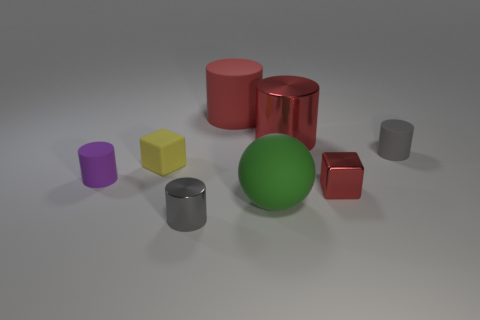Are there any other things that are the same shape as the big green thing?
Give a very brief answer. No. What number of gray objects are the same size as the matte block?
Your response must be concise. 2. How many green things are tiny matte cubes or metallic objects?
Give a very brief answer. 0. Is the number of small metal cubes that are behind the large red metallic cylinder the same as the number of metal things?
Offer a very short reply. No. There is a gray object in front of the rubber cube; how big is it?
Give a very brief answer. Small. What number of other metallic things are the same shape as the small red metal object?
Offer a very short reply. 0. What material is the object that is behind the purple thing and in front of the tiny gray rubber object?
Your answer should be compact. Rubber. Does the tiny yellow block have the same material as the big sphere?
Keep it short and to the point. Yes. What number of small red shiny balls are there?
Give a very brief answer. 0. There is a tiny cylinder in front of the tiny metallic thing that is behind the gray cylinder that is in front of the purple rubber thing; what color is it?
Provide a succinct answer. Gray. 